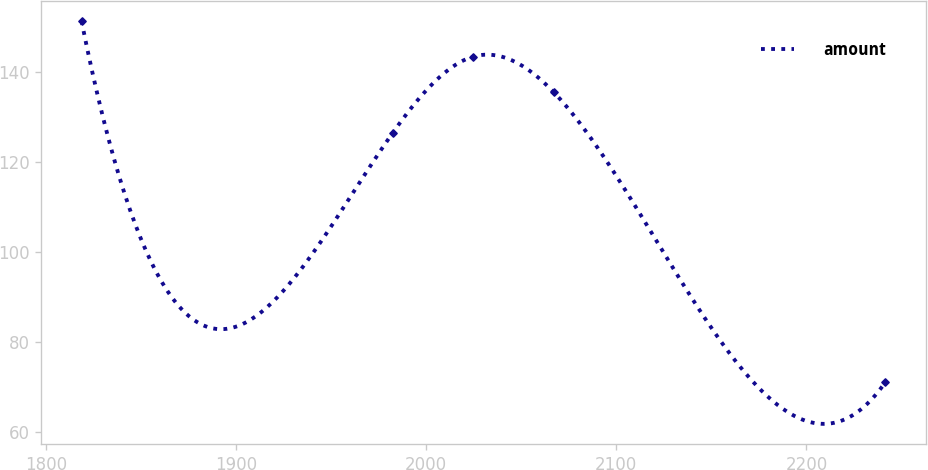Convert chart. <chart><loc_0><loc_0><loc_500><loc_500><line_chart><ecel><fcel>amount<nl><fcel>1818.69<fcel>151.4<nl><fcel>1982.45<fcel>126.58<nl><fcel>2024.74<fcel>143.5<nl><fcel>2067.03<fcel>135.6<nl><fcel>2241.57<fcel>71.09<nl></chart> 